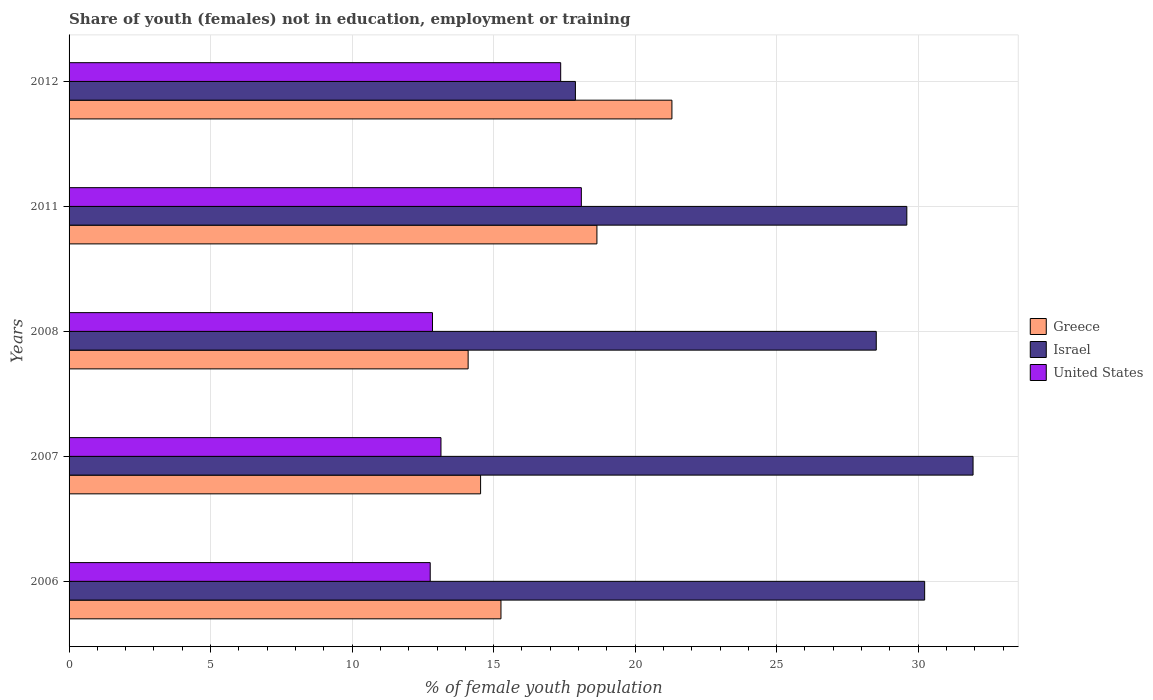How many groups of bars are there?
Make the answer very short. 5. Are the number of bars per tick equal to the number of legend labels?
Ensure brevity in your answer.  Yes. How many bars are there on the 2nd tick from the top?
Ensure brevity in your answer.  3. What is the percentage of unemployed female population in in United States in 2008?
Keep it short and to the point. 12.84. Across all years, what is the maximum percentage of unemployed female population in in Israel?
Provide a succinct answer. 31.94. Across all years, what is the minimum percentage of unemployed female population in in United States?
Keep it short and to the point. 12.76. In which year was the percentage of unemployed female population in in Israel maximum?
Provide a succinct answer. 2007. In which year was the percentage of unemployed female population in in Israel minimum?
Your answer should be very brief. 2012. What is the total percentage of unemployed female population in in United States in the graph?
Your answer should be compact. 74.21. What is the difference between the percentage of unemployed female population in in Israel in 2007 and that in 2012?
Your answer should be compact. 14.05. What is the difference between the percentage of unemployed female population in in Greece in 2006 and the percentage of unemployed female population in in United States in 2012?
Ensure brevity in your answer.  -2.11. What is the average percentage of unemployed female population in in United States per year?
Offer a very short reply. 14.84. In the year 2008, what is the difference between the percentage of unemployed female population in in Israel and percentage of unemployed female population in in United States?
Give a very brief answer. 15.68. In how many years, is the percentage of unemployed female population in in United States greater than 1 %?
Give a very brief answer. 5. What is the ratio of the percentage of unemployed female population in in United States in 2007 to that in 2011?
Offer a terse response. 0.73. Is the percentage of unemployed female population in in United States in 2006 less than that in 2007?
Your answer should be very brief. Yes. What is the difference between the highest and the second highest percentage of unemployed female population in in United States?
Offer a very short reply. 0.73. What is the difference between the highest and the lowest percentage of unemployed female population in in Israel?
Give a very brief answer. 14.05. What does the 1st bar from the bottom in 2006 represents?
Ensure brevity in your answer.  Greece. How many bars are there?
Provide a short and direct response. 15. Are all the bars in the graph horizontal?
Offer a very short reply. Yes. How many years are there in the graph?
Give a very brief answer. 5. What is the difference between two consecutive major ticks on the X-axis?
Your response must be concise. 5. How are the legend labels stacked?
Offer a terse response. Vertical. What is the title of the graph?
Your answer should be compact. Share of youth (females) not in education, employment or training. Does "East Asia (all income levels)" appear as one of the legend labels in the graph?
Give a very brief answer. No. What is the label or title of the X-axis?
Make the answer very short. % of female youth population. What is the label or title of the Y-axis?
Ensure brevity in your answer.  Years. What is the % of female youth population in Greece in 2006?
Give a very brief answer. 15.26. What is the % of female youth population of Israel in 2006?
Offer a very short reply. 30.23. What is the % of female youth population in United States in 2006?
Offer a very short reply. 12.76. What is the % of female youth population in Greece in 2007?
Make the answer very short. 14.54. What is the % of female youth population in Israel in 2007?
Keep it short and to the point. 31.94. What is the % of female youth population of United States in 2007?
Provide a short and direct response. 13.14. What is the % of female youth population in Greece in 2008?
Your answer should be compact. 14.1. What is the % of female youth population of Israel in 2008?
Offer a very short reply. 28.52. What is the % of female youth population of United States in 2008?
Provide a short and direct response. 12.84. What is the % of female youth population in Greece in 2011?
Ensure brevity in your answer.  18.65. What is the % of female youth population in Israel in 2011?
Ensure brevity in your answer.  29.6. What is the % of female youth population in United States in 2011?
Offer a very short reply. 18.1. What is the % of female youth population of Greece in 2012?
Provide a short and direct response. 21.3. What is the % of female youth population of Israel in 2012?
Offer a very short reply. 17.89. What is the % of female youth population in United States in 2012?
Provide a succinct answer. 17.37. Across all years, what is the maximum % of female youth population of Greece?
Offer a very short reply. 21.3. Across all years, what is the maximum % of female youth population of Israel?
Provide a succinct answer. 31.94. Across all years, what is the maximum % of female youth population in United States?
Your answer should be compact. 18.1. Across all years, what is the minimum % of female youth population of Greece?
Your response must be concise. 14.1. Across all years, what is the minimum % of female youth population in Israel?
Make the answer very short. 17.89. Across all years, what is the minimum % of female youth population of United States?
Ensure brevity in your answer.  12.76. What is the total % of female youth population in Greece in the graph?
Keep it short and to the point. 83.85. What is the total % of female youth population of Israel in the graph?
Keep it short and to the point. 138.18. What is the total % of female youth population in United States in the graph?
Keep it short and to the point. 74.21. What is the difference between the % of female youth population in Greece in 2006 and that in 2007?
Your response must be concise. 0.72. What is the difference between the % of female youth population of Israel in 2006 and that in 2007?
Keep it short and to the point. -1.71. What is the difference between the % of female youth population of United States in 2006 and that in 2007?
Provide a succinct answer. -0.38. What is the difference between the % of female youth population of Greece in 2006 and that in 2008?
Offer a very short reply. 1.16. What is the difference between the % of female youth population of Israel in 2006 and that in 2008?
Make the answer very short. 1.71. What is the difference between the % of female youth population in United States in 2006 and that in 2008?
Your answer should be very brief. -0.08. What is the difference between the % of female youth population of Greece in 2006 and that in 2011?
Provide a succinct answer. -3.39. What is the difference between the % of female youth population of Israel in 2006 and that in 2011?
Keep it short and to the point. 0.63. What is the difference between the % of female youth population in United States in 2006 and that in 2011?
Provide a succinct answer. -5.34. What is the difference between the % of female youth population in Greece in 2006 and that in 2012?
Offer a very short reply. -6.04. What is the difference between the % of female youth population in Israel in 2006 and that in 2012?
Your answer should be very brief. 12.34. What is the difference between the % of female youth population of United States in 2006 and that in 2012?
Your response must be concise. -4.61. What is the difference between the % of female youth population of Greece in 2007 and that in 2008?
Offer a very short reply. 0.44. What is the difference between the % of female youth population of Israel in 2007 and that in 2008?
Provide a succinct answer. 3.42. What is the difference between the % of female youth population in Greece in 2007 and that in 2011?
Offer a very short reply. -4.11. What is the difference between the % of female youth population of Israel in 2007 and that in 2011?
Give a very brief answer. 2.34. What is the difference between the % of female youth population of United States in 2007 and that in 2011?
Ensure brevity in your answer.  -4.96. What is the difference between the % of female youth population of Greece in 2007 and that in 2012?
Your answer should be compact. -6.76. What is the difference between the % of female youth population in Israel in 2007 and that in 2012?
Keep it short and to the point. 14.05. What is the difference between the % of female youth population of United States in 2007 and that in 2012?
Give a very brief answer. -4.23. What is the difference between the % of female youth population of Greece in 2008 and that in 2011?
Your response must be concise. -4.55. What is the difference between the % of female youth population of Israel in 2008 and that in 2011?
Make the answer very short. -1.08. What is the difference between the % of female youth population in United States in 2008 and that in 2011?
Offer a very short reply. -5.26. What is the difference between the % of female youth population of Greece in 2008 and that in 2012?
Keep it short and to the point. -7.2. What is the difference between the % of female youth population in Israel in 2008 and that in 2012?
Your response must be concise. 10.63. What is the difference between the % of female youth population of United States in 2008 and that in 2012?
Offer a terse response. -4.53. What is the difference between the % of female youth population of Greece in 2011 and that in 2012?
Make the answer very short. -2.65. What is the difference between the % of female youth population in Israel in 2011 and that in 2012?
Offer a very short reply. 11.71. What is the difference between the % of female youth population in United States in 2011 and that in 2012?
Your answer should be compact. 0.73. What is the difference between the % of female youth population in Greece in 2006 and the % of female youth population in Israel in 2007?
Your answer should be compact. -16.68. What is the difference between the % of female youth population of Greece in 2006 and the % of female youth population of United States in 2007?
Provide a short and direct response. 2.12. What is the difference between the % of female youth population of Israel in 2006 and the % of female youth population of United States in 2007?
Offer a terse response. 17.09. What is the difference between the % of female youth population in Greece in 2006 and the % of female youth population in Israel in 2008?
Give a very brief answer. -13.26. What is the difference between the % of female youth population of Greece in 2006 and the % of female youth population of United States in 2008?
Keep it short and to the point. 2.42. What is the difference between the % of female youth population of Israel in 2006 and the % of female youth population of United States in 2008?
Make the answer very short. 17.39. What is the difference between the % of female youth population of Greece in 2006 and the % of female youth population of Israel in 2011?
Provide a succinct answer. -14.34. What is the difference between the % of female youth population in Greece in 2006 and the % of female youth population in United States in 2011?
Your answer should be compact. -2.84. What is the difference between the % of female youth population of Israel in 2006 and the % of female youth population of United States in 2011?
Your response must be concise. 12.13. What is the difference between the % of female youth population in Greece in 2006 and the % of female youth population in Israel in 2012?
Offer a terse response. -2.63. What is the difference between the % of female youth population in Greece in 2006 and the % of female youth population in United States in 2012?
Provide a succinct answer. -2.11. What is the difference between the % of female youth population in Israel in 2006 and the % of female youth population in United States in 2012?
Give a very brief answer. 12.86. What is the difference between the % of female youth population of Greece in 2007 and the % of female youth population of Israel in 2008?
Ensure brevity in your answer.  -13.98. What is the difference between the % of female youth population of Israel in 2007 and the % of female youth population of United States in 2008?
Offer a very short reply. 19.1. What is the difference between the % of female youth population of Greece in 2007 and the % of female youth population of Israel in 2011?
Your response must be concise. -15.06. What is the difference between the % of female youth population of Greece in 2007 and the % of female youth population of United States in 2011?
Provide a short and direct response. -3.56. What is the difference between the % of female youth population of Israel in 2007 and the % of female youth population of United States in 2011?
Keep it short and to the point. 13.84. What is the difference between the % of female youth population of Greece in 2007 and the % of female youth population of Israel in 2012?
Make the answer very short. -3.35. What is the difference between the % of female youth population of Greece in 2007 and the % of female youth population of United States in 2012?
Offer a very short reply. -2.83. What is the difference between the % of female youth population of Israel in 2007 and the % of female youth population of United States in 2012?
Offer a very short reply. 14.57. What is the difference between the % of female youth population of Greece in 2008 and the % of female youth population of Israel in 2011?
Ensure brevity in your answer.  -15.5. What is the difference between the % of female youth population in Greece in 2008 and the % of female youth population in United States in 2011?
Offer a very short reply. -4. What is the difference between the % of female youth population of Israel in 2008 and the % of female youth population of United States in 2011?
Make the answer very short. 10.42. What is the difference between the % of female youth population in Greece in 2008 and the % of female youth population in Israel in 2012?
Keep it short and to the point. -3.79. What is the difference between the % of female youth population of Greece in 2008 and the % of female youth population of United States in 2012?
Make the answer very short. -3.27. What is the difference between the % of female youth population of Israel in 2008 and the % of female youth population of United States in 2012?
Your answer should be compact. 11.15. What is the difference between the % of female youth population of Greece in 2011 and the % of female youth population of Israel in 2012?
Your response must be concise. 0.76. What is the difference between the % of female youth population of Greece in 2011 and the % of female youth population of United States in 2012?
Keep it short and to the point. 1.28. What is the difference between the % of female youth population of Israel in 2011 and the % of female youth population of United States in 2012?
Keep it short and to the point. 12.23. What is the average % of female youth population of Greece per year?
Ensure brevity in your answer.  16.77. What is the average % of female youth population of Israel per year?
Your answer should be compact. 27.64. What is the average % of female youth population of United States per year?
Provide a succinct answer. 14.84. In the year 2006, what is the difference between the % of female youth population of Greece and % of female youth population of Israel?
Provide a short and direct response. -14.97. In the year 2006, what is the difference between the % of female youth population in Greece and % of female youth population in United States?
Offer a terse response. 2.5. In the year 2006, what is the difference between the % of female youth population in Israel and % of female youth population in United States?
Your response must be concise. 17.47. In the year 2007, what is the difference between the % of female youth population of Greece and % of female youth population of Israel?
Provide a short and direct response. -17.4. In the year 2008, what is the difference between the % of female youth population in Greece and % of female youth population in Israel?
Your answer should be compact. -14.42. In the year 2008, what is the difference between the % of female youth population of Greece and % of female youth population of United States?
Offer a terse response. 1.26. In the year 2008, what is the difference between the % of female youth population of Israel and % of female youth population of United States?
Provide a short and direct response. 15.68. In the year 2011, what is the difference between the % of female youth population of Greece and % of female youth population of Israel?
Make the answer very short. -10.95. In the year 2011, what is the difference between the % of female youth population in Greece and % of female youth population in United States?
Keep it short and to the point. 0.55. In the year 2012, what is the difference between the % of female youth population in Greece and % of female youth population in Israel?
Give a very brief answer. 3.41. In the year 2012, what is the difference between the % of female youth population in Greece and % of female youth population in United States?
Your answer should be compact. 3.93. In the year 2012, what is the difference between the % of female youth population in Israel and % of female youth population in United States?
Your answer should be very brief. 0.52. What is the ratio of the % of female youth population of Greece in 2006 to that in 2007?
Your answer should be compact. 1.05. What is the ratio of the % of female youth population of Israel in 2006 to that in 2007?
Give a very brief answer. 0.95. What is the ratio of the % of female youth population of United States in 2006 to that in 2007?
Provide a succinct answer. 0.97. What is the ratio of the % of female youth population of Greece in 2006 to that in 2008?
Your answer should be very brief. 1.08. What is the ratio of the % of female youth population in Israel in 2006 to that in 2008?
Provide a succinct answer. 1.06. What is the ratio of the % of female youth population in Greece in 2006 to that in 2011?
Ensure brevity in your answer.  0.82. What is the ratio of the % of female youth population of Israel in 2006 to that in 2011?
Provide a succinct answer. 1.02. What is the ratio of the % of female youth population of United States in 2006 to that in 2011?
Offer a terse response. 0.7. What is the ratio of the % of female youth population in Greece in 2006 to that in 2012?
Keep it short and to the point. 0.72. What is the ratio of the % of female youth population of Israel in 2006 to that in 2012?
Make the answer very short. 1.69. What is the ratio of the % of female youth population in United States in 2006 to that in 2012?
Provide a short and direct response. 0.73. What is the ratio of the % of female youth population of Greece in 2007 to that in 2008?
Provide a succinct answer. 1.03. What is the ratio of the % of female youth population in Israel in 2007 to that in 2008?
Offer a terse response. 1.12. What is the ratio of the % of female youth population in United States in 2007 to that in 2008?
Provide a succinct answer. 1.02. What is the ratio of the % of female youth population of Greece in 2007 to that in 2011?
Offer a terse response. 0.78. What is the ratio of the % of female youth population in Israel in 2007 to that in 2011?
Make the answer very short. 1.08. What is the ratio of the % of female youth population of United States in 2007 to that in 2011?
Your response must be concise. 0.73. What is the ratio of the % of female youth population in Greece in 2007 to that in 2012?
Give a very brief answer. 0.68. What is the ratio of the % of female youth population in Israel in 2007 to that in 2012?
Ensure brevity in your answer.  1.79. What is the ratio of the % of female youth population in United States in 2007 to that in 2012?
Provide a short and direct response. 0.76. What is the ratio of the % of female youth population in Greece in 2008 to that in 2011?
Keep it short and to the point. 0.76. What is the ratio of the % of female youth population of Israel in 2008 to that in 2011?
Keep it short and to the point. 0.96. What is the ratio of the % of female youth population of United States in 2008 to that in 2011?
Give a very brief answer. 0.71. What is the ratio of the % of female youth population of Greece in 2008 to that in 2012?
Your answer should be very brief. 0.66. What is the ratio of the % of female youth population of Israel in 2008 to that in 2012?
Ensure brevity in your answer.  1.59. What is the ratio of the % of female youth population of United States in 2008 to that in 2012?
Offer a terse response. 0.74. What is the ratio of the % of female youth population in Greece in 2011 to that in 2012?
Your answer should be very brief. 0.88. What is the ratio of the % of female youth population of Israel in 2011 to that in 2012?
Give a very brief answer. 1.65. What is the ratio of the % of female youth population of United States in 2011 to that in 2012?
Offer a very short reply. 1.04. What is the difference between the highest and the second highest % of female youth population in Greece?
Keep it short and to the point. 2.65. What is the difference between the highest and the second highest % of female youth population in Israel?
Give a very brief answer. 1.71. What is the difference between the highest and the second highest % of female youth population in United States?
Ensure brevity in your answer.  0.73. What is the difference between the highest and the lowest % of female youth population of Greece?
Your answer should be very brief. 7.2. What is the difference between the highest and the lowest % of female youth population of Israel?
Your response must be concise. 14.05. What is the difference between the highest and the lowest % of female youth population in United States?
Provide a succinct answer. 5.34. 